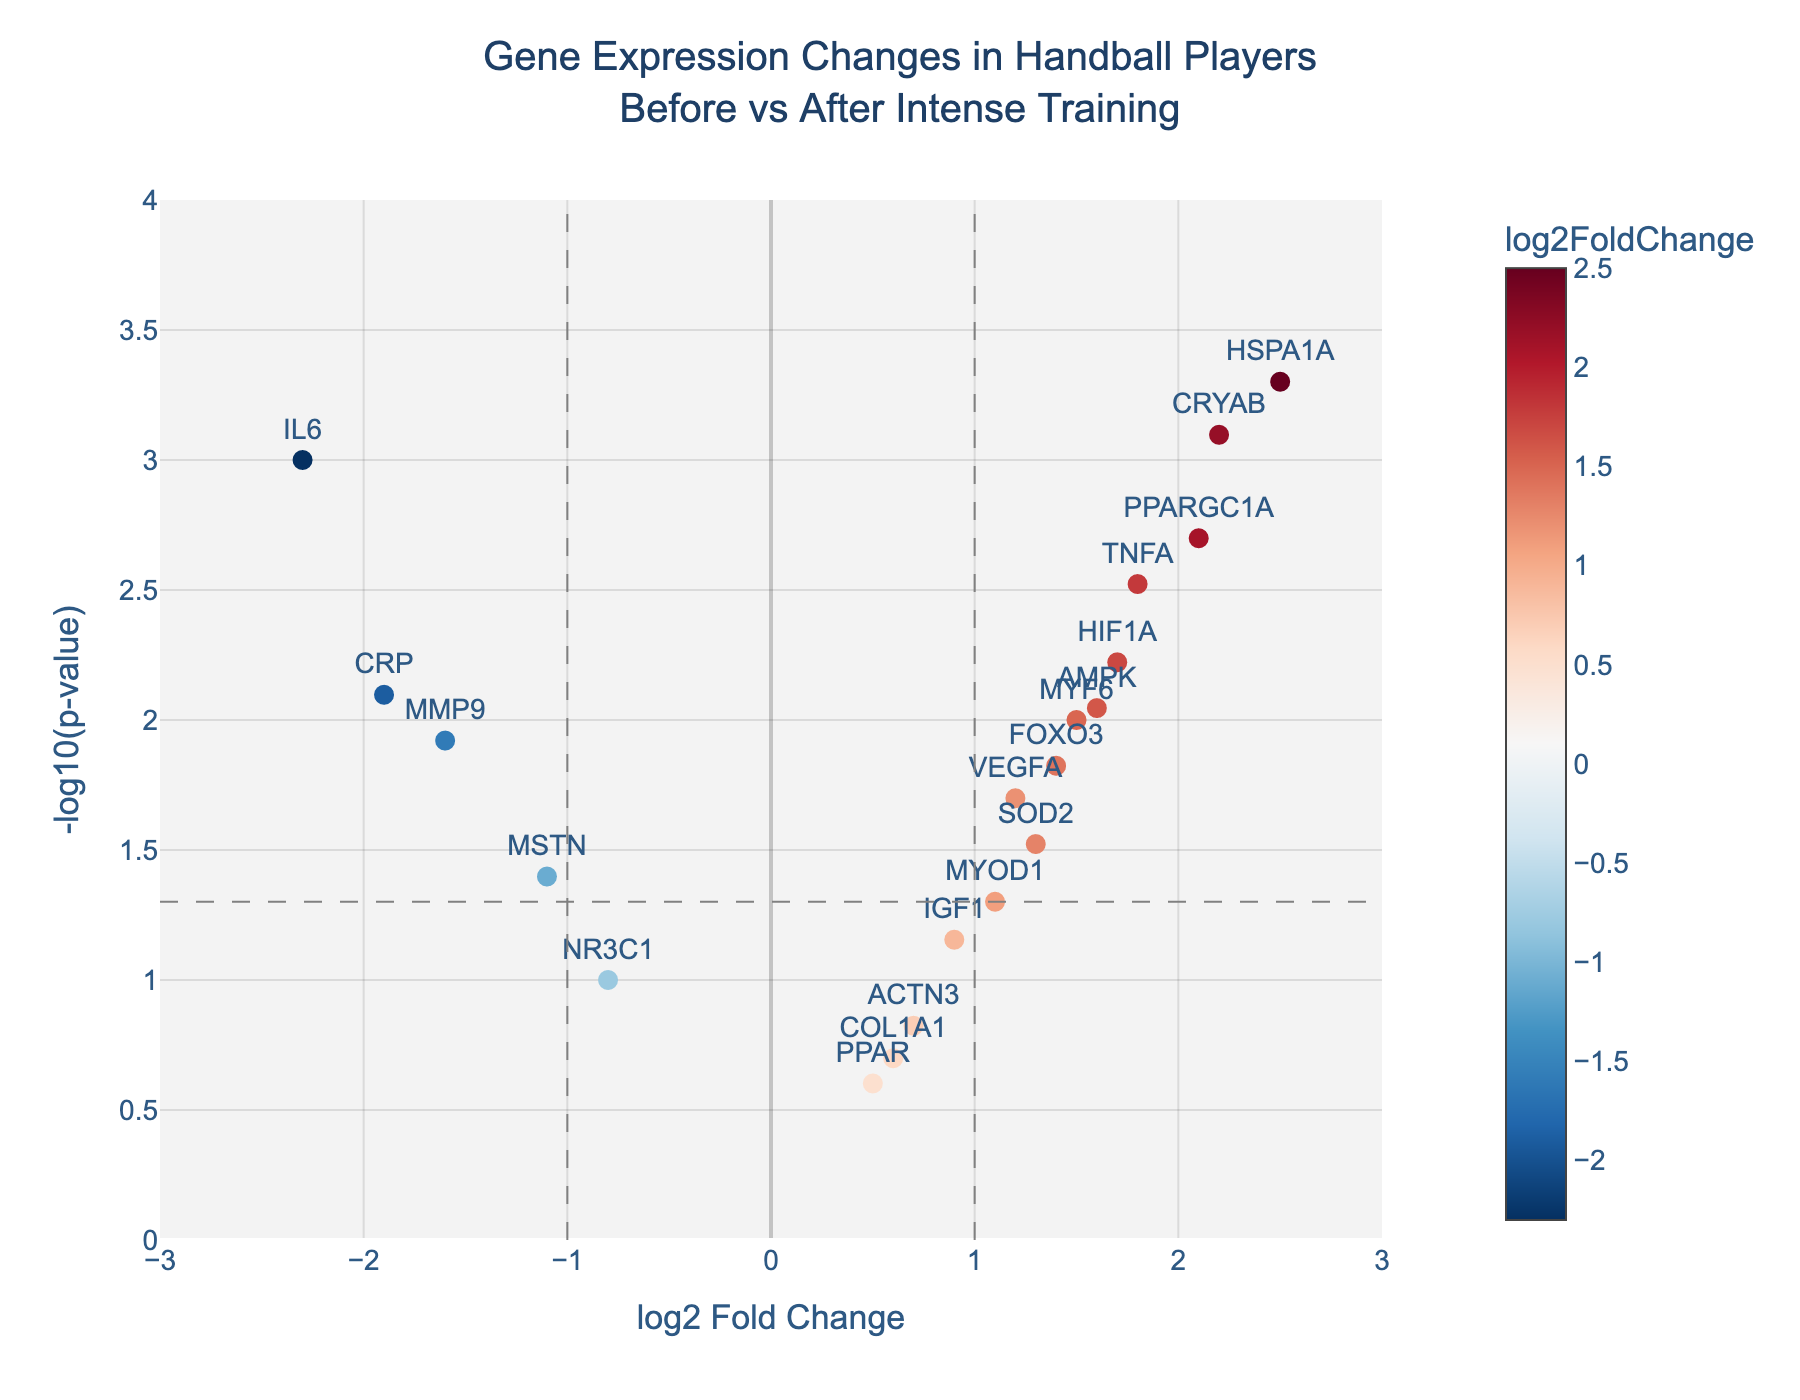what is the title of the figure? The title of the figure is located at the top, center position, and it informs about the content of the plot.
Answer: Gene Expression Changes in Handball Players Before vs After Intense Training How many genes showed a significant expression change (p-value < 0.05)? The horizontal dashed line represents the threshold where the p-value is 0.05, and points above this line show significant changes in expression.
Answer: 13 Which genes have a log2 fold change greater than 2? To find these genes, look at the points to the right of the vertical dashed line at log2 fold change = 2.
Answer: HSPA1A, CRYAB Which gene has the lowest log2 fold change? Look for the gene at the farthest left position on the x-axis.
Answer: IL6 What is the p-value of the gene TNFA? Hover over the gene TNFA to see the detailed hover text, which includes its p-value.
Answer: 0.003 Which gene has the highest -log10(p-value)? Identify the point that is highest on the y-axis of the plot.
Answer: HSPA1A Are there more genes upregulated (log2 fold change > 0) or downregulated (log2 fold change < 0)? Count the number of points to the right and left of the vertical dashed line at log2 fold change = 0.
Answer: More genes are upregulated Compare the significance (p-values) of genes PPARGC1A and MYF6: which is more significant? Compare the y-positions (since higher -log10(p-value) means more significant) of PPARGC1A and MYF6.
Answer: PPARGC1A Which has a greater absolute log2 fold change, CRP or MMP9? Compare the distance from zero (regardless of direction) on the x-axis for CRP and MMP9.
Answer: CRP How does the expression of AMPK change after intense training? Look at the x-axis value for AMPK; positive values indicate upregulation and negative values indicate downregulation.
Answer: Upregulated 